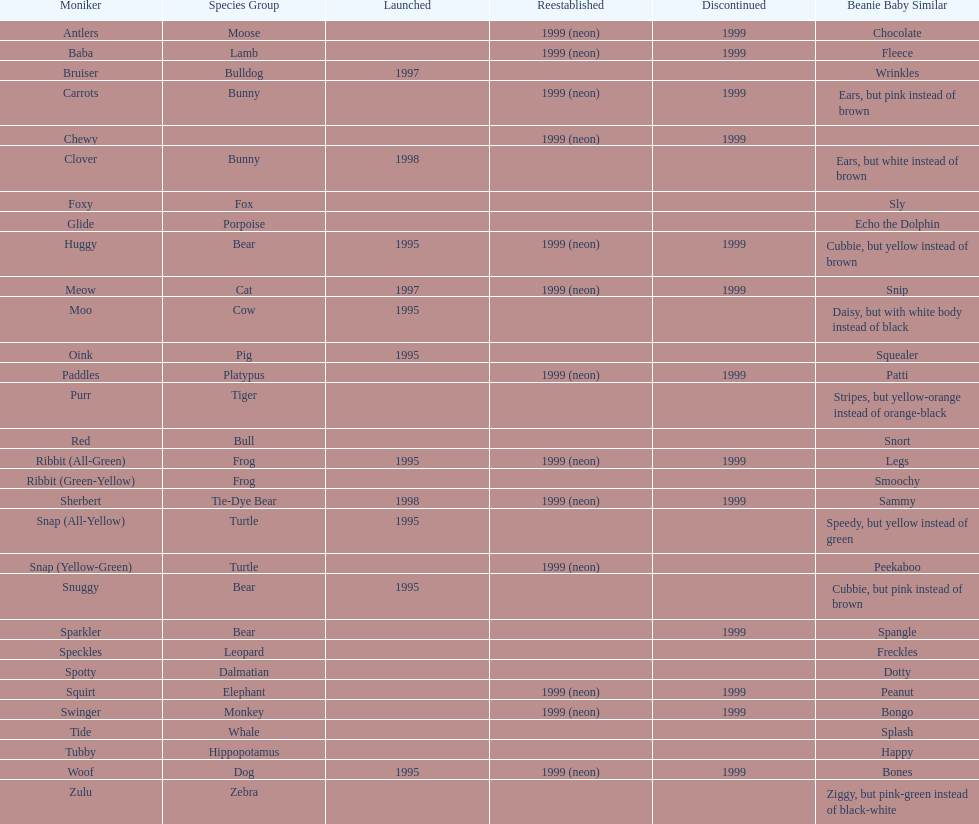In what year were the first pillow pals introduced? 1995. 